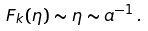<formula> <loc_0><loc_0><loc_500><loc_500>F _ { k } ( \eta ) \sim \eta \sim a ^ { - 1 } \, .</formula> 